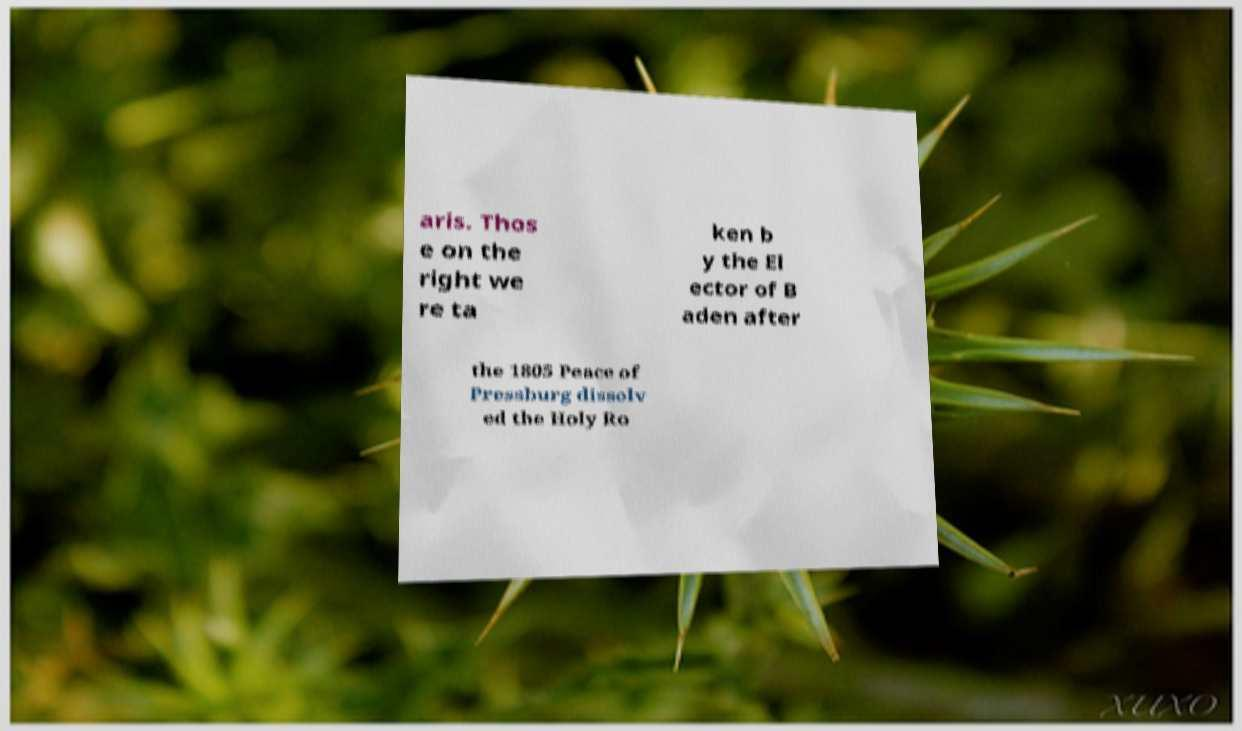Could you extract and type out the text from this image? aris. Thos e on the right we re ta ken b y the El ector of B aden after the 1805 Peace of Pressburg dissolv ed the Holy Ro 